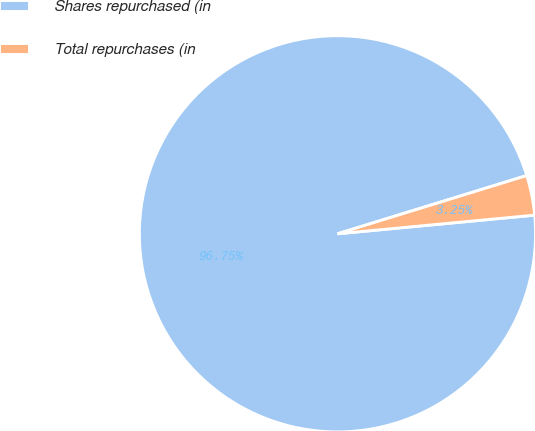Convert chart to OTSL. <chart><loc_0><loc_0><loc_500><loc_500><pie_chart><fcel>Shares repurchased (in<fcel>Total repurchases (in<nl><fcel>96.75%<fcel>3.25%<nl></chart> 